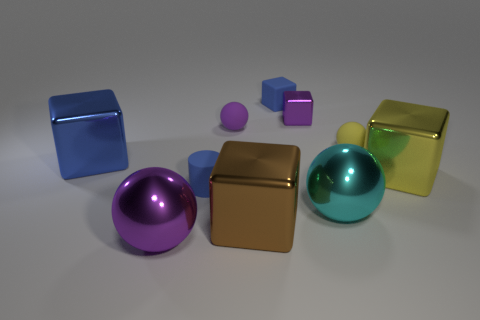How big is the purple matte ball?
Offer a very short reply. Small. What is the size of the purple thing that is the same shape as the brown thing?
Keep it short and to the point. Small. What is the size of the rubber ball right of the large block that is in front of the large cyan metal thing?
Ensure brevity in your answer.  Small. What is the color of the rubber object that is the same shape as the big brown metallic thing?
Your answer should be very brief. Blue. How many metallic objects are the same color as the small cylinder?
Offer a very short reply. 1. Do the cyan metallic thing and the yellow matte thing have the same size?
Your answer should be compact. No. What is the tiny purple ball made of?
Provide a short and direct response. Rubber. There is a small cube that is made of the same material as the small blue cylinder; what is its color?
Provide a succinct answer. Blue. Does the big brown block have the same material as the large object in front of the brown block?
Make the answer very short. Yes. What number of yellow balls are the same material as the cylinder?
Provide a short and direct response. 1. 